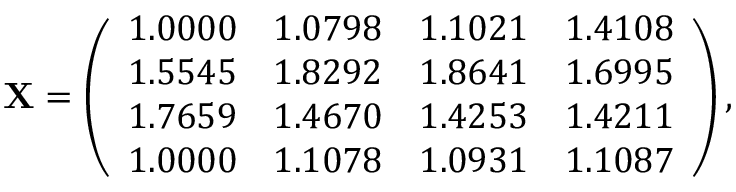Convert formula to latex. <formula><loc_0><loc_0><loc_500><loc_500>X = \left ( \begin{array} { c c c c } { 1 . 0 0 0 0 } & { 1 . 0 7 9 8 } & { 1 . 1 0 2 1 } & { 1 . 4 1 0 8 } \\ { 1 . 5 5 4 5 } & { 1 . 8 2 9 2 } & { 1 . 8 6 4 1 } & { 1 . 6 9 9 5 } \\ { 1 . 7 6 5 9 } & { 1 . 4 6 7 0 } & { 1 . 4 2 5 3 } & { 1 . 4 2 1 1 } \\ { 1 . 0 0 0 0 } & { 1 . 1 0 7 8 } & { 1 . 0 9 3 1 } & { 1 . 1 0 8 7 } \end{array} \right ) ,</formula> 